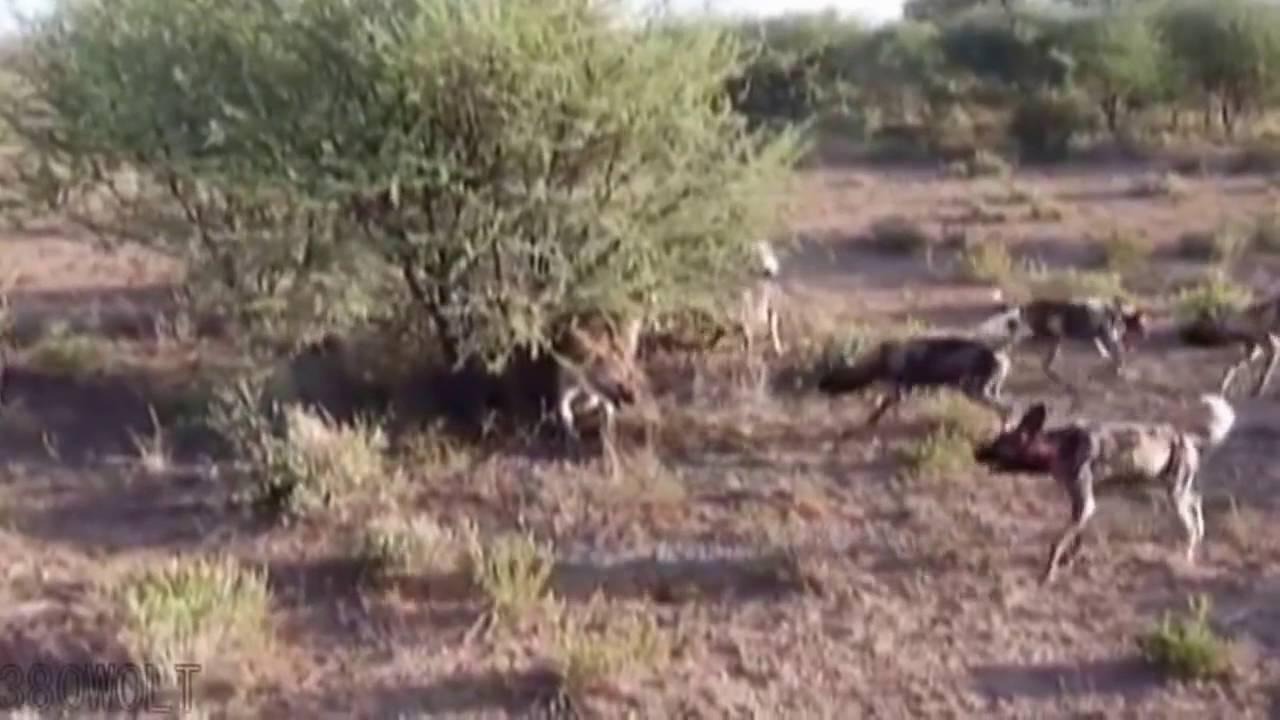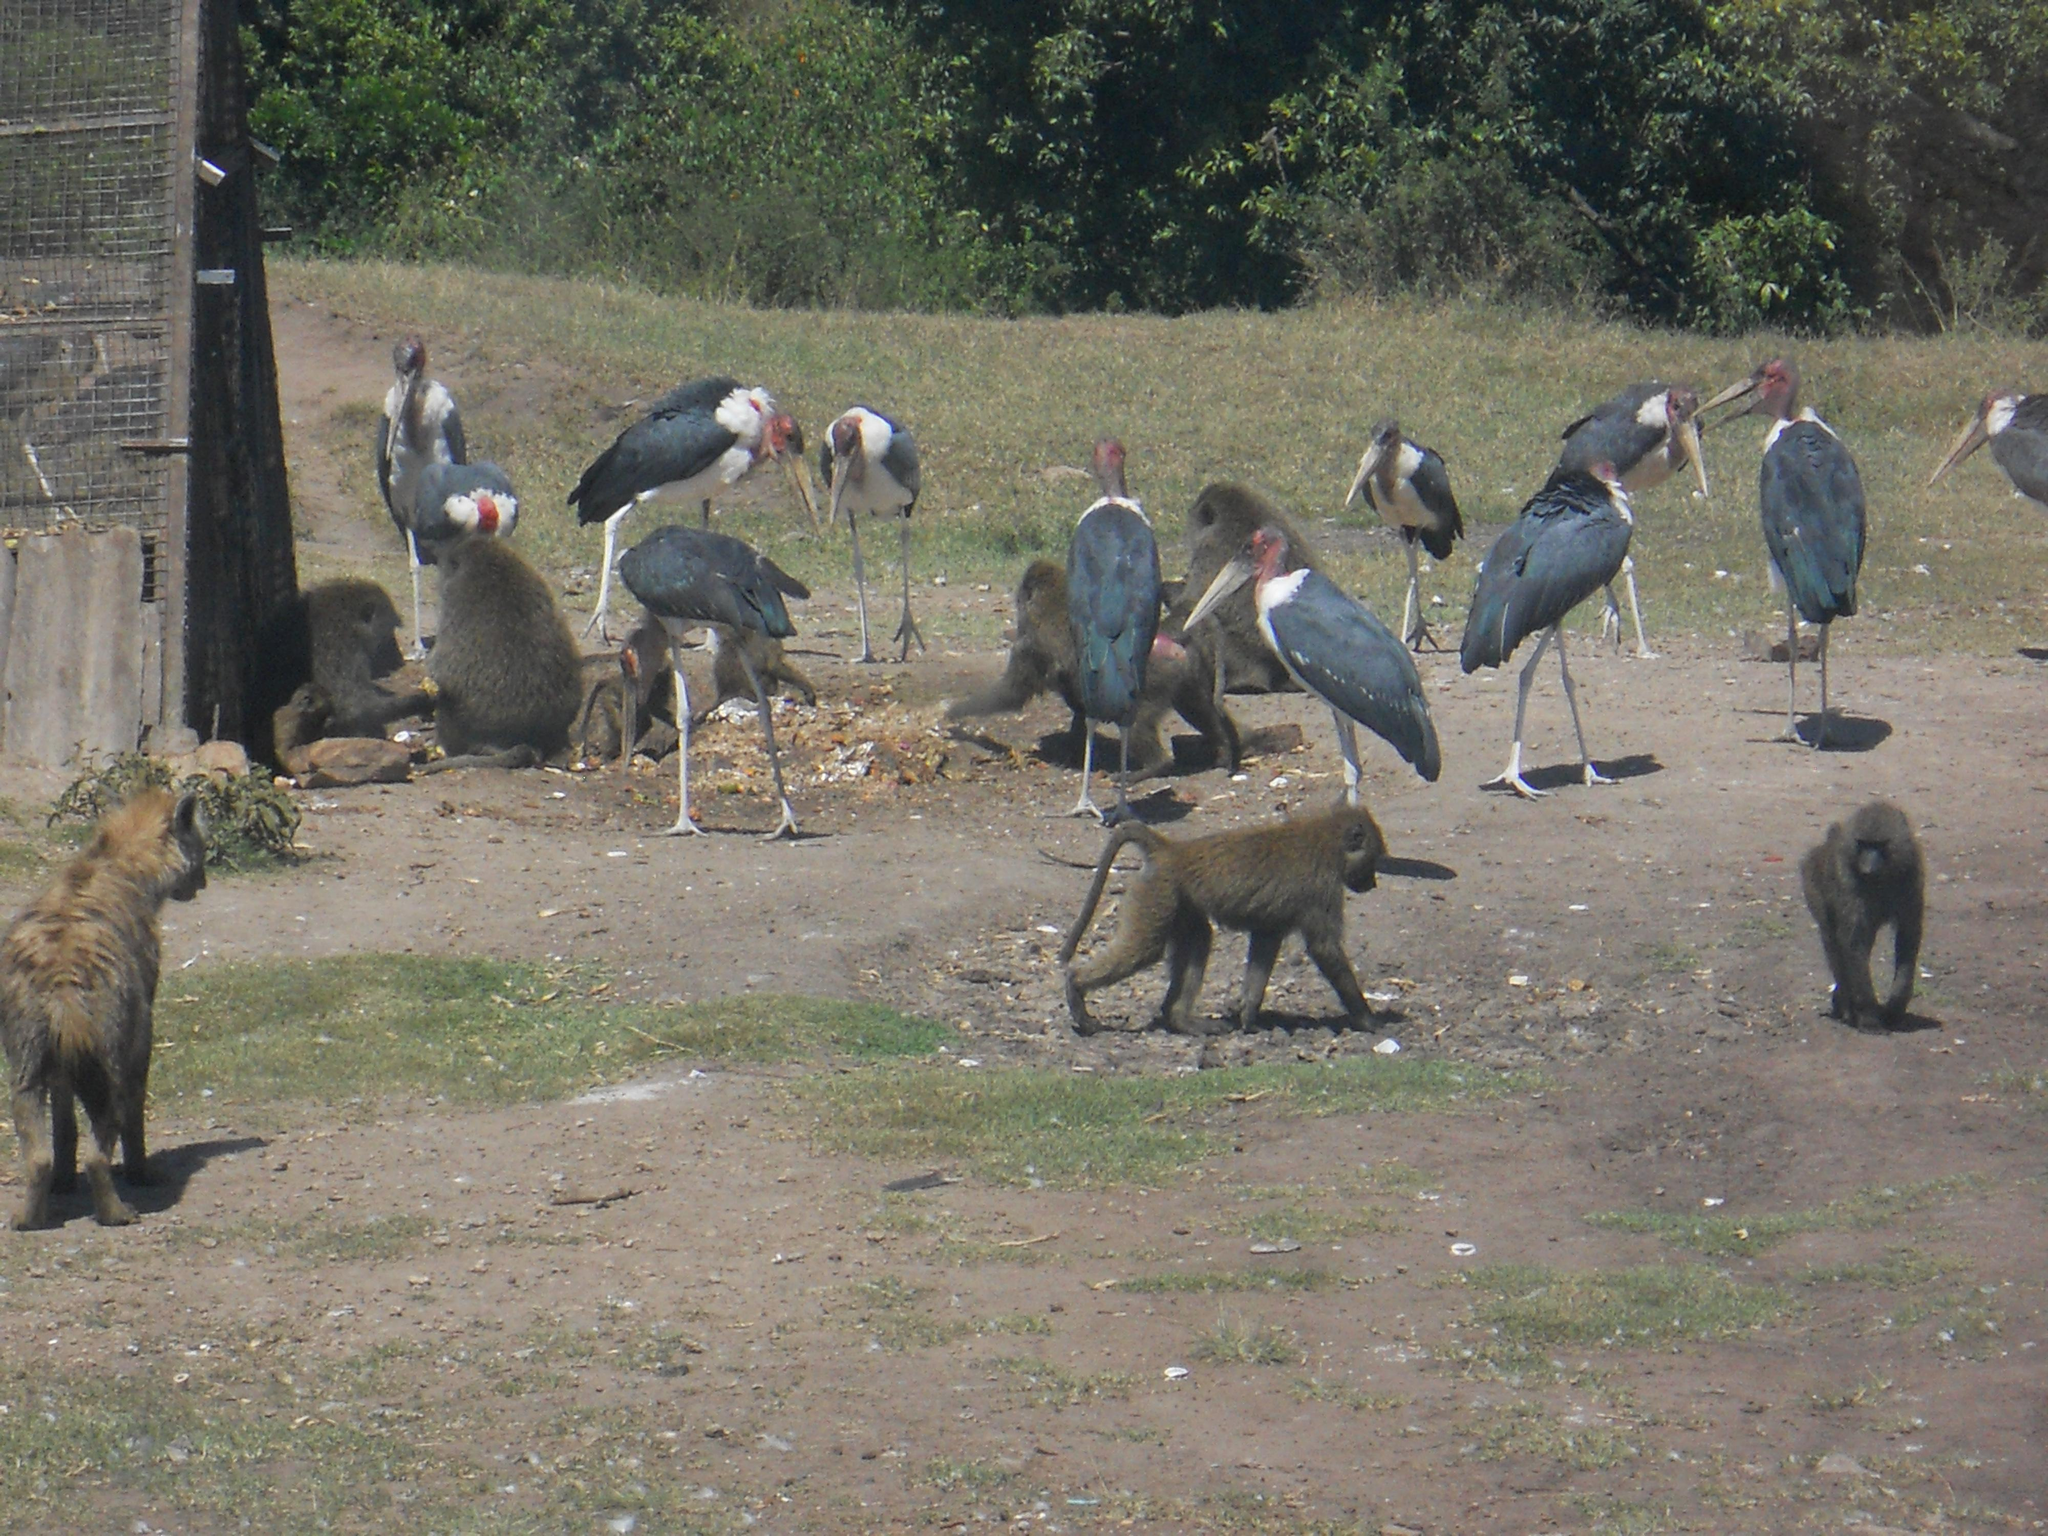The first image is the image on the left, the second image is the image on the right. Considering the images on both sides, is "There are at least six wild dogs are standing on the shore line." valid? Answer yes or no. No. 